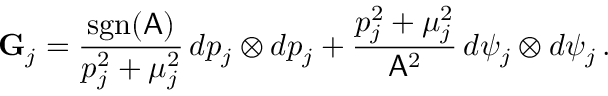<formula> <loc_0><loc_0><loc_500><loc_500>G _ { j } = \frac { s g n ( A ) } { p _ { j } ^ { 2 } + \mu _ { j } ^ { 2 } } \, d p _ { j } \otimes d p _ { j } + \frac { p _ { j } ^ { 2 } + \mu _ { j } ^ { 2 } } { A ^ { 2 } } \, d \psi _ { j } \otimes d \psi _ { j } \, .</formula> 